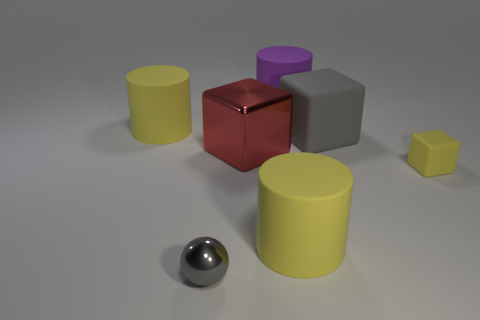Can you describe the arrangement of the objects? The objects are scattered with no discernible pattern on a flat surface. There's a mix of geometric shapes like cubes, cylinders, and a sphere in various colors.  What colors are the cylinders? There are three cylinders in the image: one is yellow, one is pale yellow or cream, and the third one has a silvery metallic finish. 